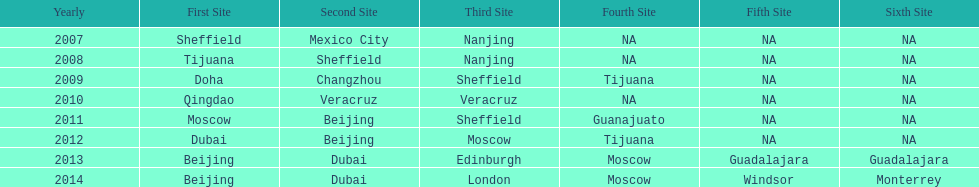What was the last year where tijuana was a venue? 2012. 